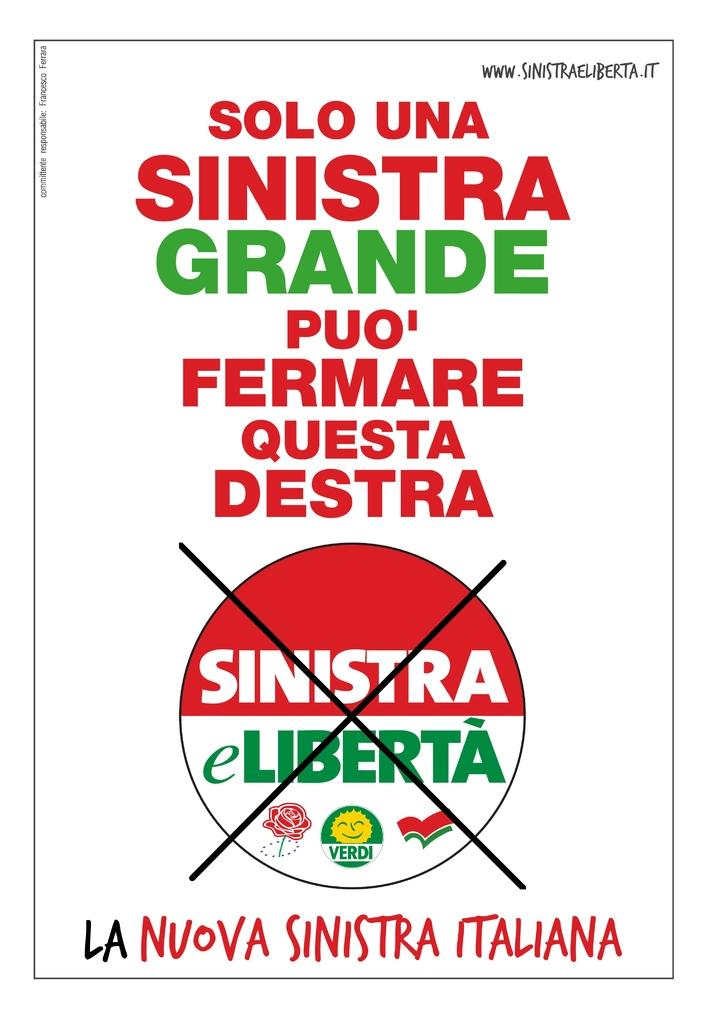<image>
Render a clear and concise summary of the photo. Poster that has the words "Sinistra eLiberta" crossed out. 